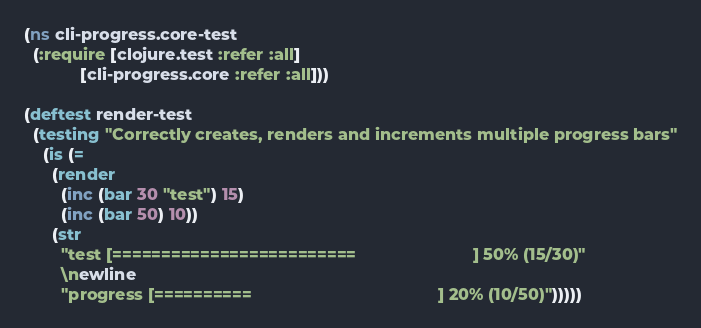Convert code to text. <code><loc_0><loc_0><loc_500><loc_500><_Clojure_>(ns cli-progress.core-test
  (:require [clojure.test :refer :all]
            [cli-progress.core :refer :all]))

(deftest render-test
  (testing "Correctly creates, renders and increments multiple progress bars"
    (is (=
      (render
        (inc (bar 30 "test") 15)
        (inc (bar 50) 10))
      (str
        "test [=========================                         ] 50% (15/30)"
        \newline
        "progress [==========                                        ] 20% (10/50)")))))
</code> 